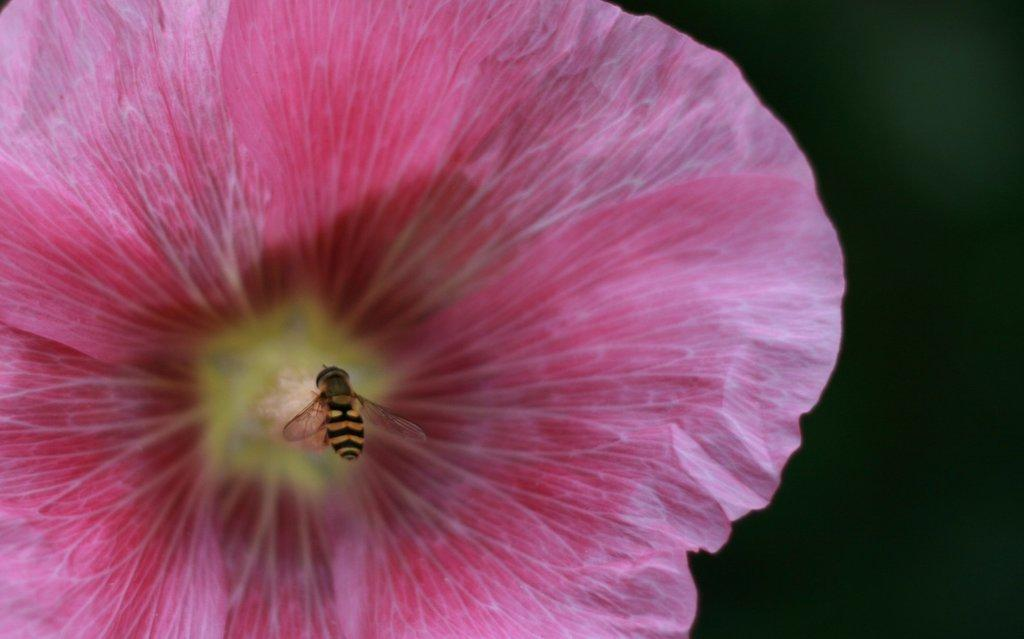What is the main subject of the image? The main subject of the image is an insect on a flower. Can you describe the background or surroundings in the image? There is a dark view on the right side of the image. How many feet of sand can be seen in the image? There is no sand present in the image. What level of difficulty is the insect facing while on the flower in the image? The image does not provide information about the difficulty level for the insect. 